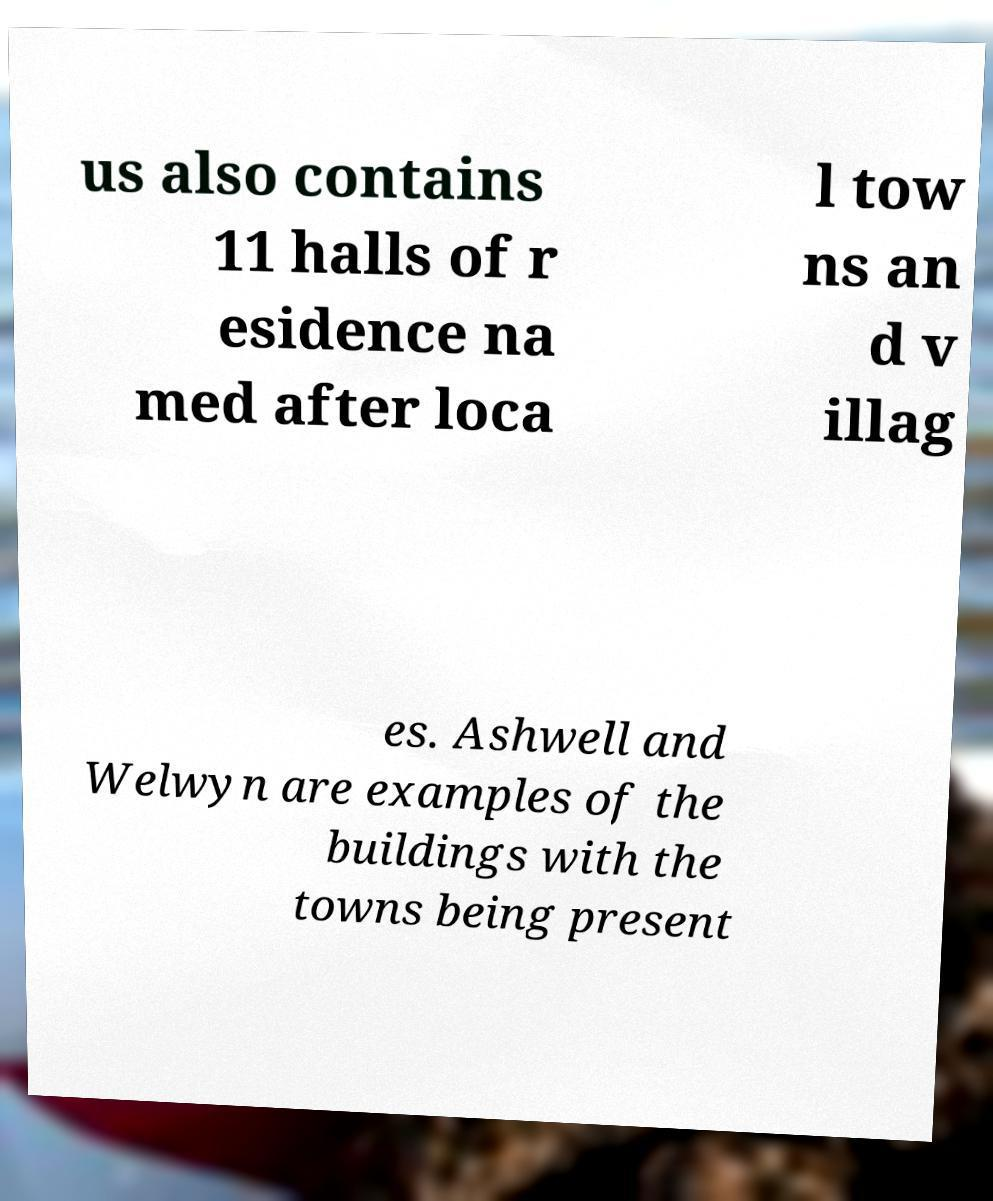Please identify and transcribe the text found in this image. us also contains 11 halls of r esidence na med after loca l tow ns an d v illag es. Ashwell and Welwyn are examples of the buildings with the towns being present 